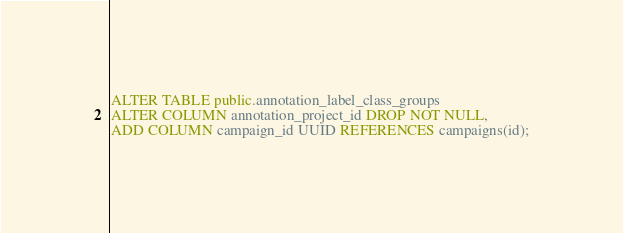Convert code to text. <code><loc_0><loc_0><loc_500><loc_500><_SQL_>ALTER TABLE public.annotation_label_class_groups
ALTER COLUMN annotation_project_id DROP NOT NULL,
ADD COLUMN campaign_id UUID REFERENCES campaigns(id);</code> 